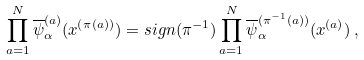Convert formula to latex. <formula><loc_0><loc_0><loc_500><loc_500>\prod _ { a = 1 } ^ { N } \overline { \psi } ^ { ( a ) } _ { \alpha } ( x ^ { ( \pi ( a ) ) } ) = s i g n ( \pi ^ { - 1 } ) \prod _ { a = 1 } ^ { N } \overline { \psi } ^ { ( \pi ^ { - 1 } ( a ) ) } _ { \alpha } ( x ^ { ( a ) } ) \, ,</formula> 